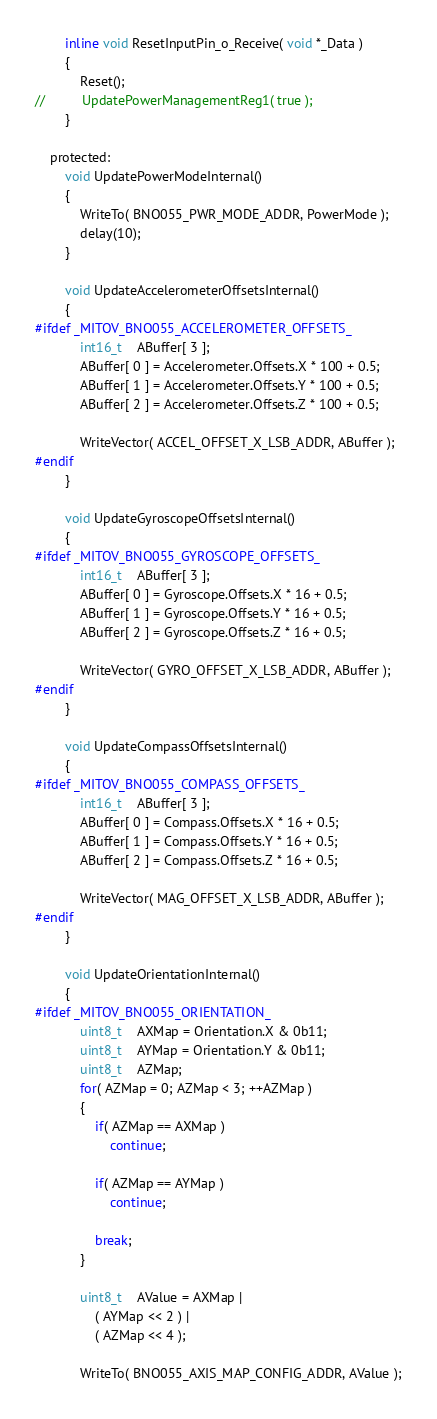Convert code to text. <code><loc_0><loc_0><loc_500><loc_500><_C_>
		inline void ResetInputPin_o_Receive( void *_Data )
		{
			Reset();
//			UpdatePowerManagementReg1( true );
		}

	protected:
		void UpdatePowerModeInternal()
		{
			WriteTo( BNO055_PWR_MODE_ADDR, PowerMode );
			delay(10);
		}

		void UpdateAccelerometerOffsetsInternal()
		{
#ifdef _MITOV_BNO055_ACCELEROMETER_OFFSETS_
			int16_t	ABuffer[ 3 ];
			ABuffer[ 0 ] = Accelerometer.Offsets.X * 100 + 0.5;
			ABuffer[ 1 ] = Accelerometer.Offsets.Y * 100 + 0.5;
			ABuffer[ 2 ] = Accelerometer.Offsets.Z * 100 + 0.5;

			WriteVector( ACCEL_OFFSET_X_LSB_ADDR, ABuffer );
#endif
		}

		void UpdateGyroscopeOffsetsInternal()
		{
#ifdef _MITOV_BNO055_GYROSCOPE_OFFSETS_
			int16_t	ABuffer[ 3 ];
			ABuffer[ 0 ] = Gyroscope.Offsets.X * 16 + 0.5;
			ABuffer[ 1 ] = Gyroscope.Offsets.Y * 16 + 0.5;
			ABuffer[ 2 ] = Gyroscope.Offsets.Z * 16 + 0.5;

			WriteVector( GYRO_OFFSET_X_LSB_ADDR, ABuffer );
#endif
		}

		void UpdateCompassOffsetsInternal()
		{
#ifdef _MITOV_BNO055_COMPASS_OFFSETS_
			int16_t	ABuffer[ 3 ];
			ABuffer[ 0 ] = Compass.Offsets.X * 16 + 0.5;
			ABuffer[ 1 ] = Compass.Offsets.Y * 16 + 0.5;
			ABuffer[ 2 ] = Compass.Offsets.Z * 16 + 0.5;

			WriteVector( MAG_OFFSET_X_LSB_ADDR, ABuffer );
#endif
		}

		void UpdateOrientationInternal()
		{
#ifdef _MITOV_BNO055_ORIENTATION_
			uint8_t	AXMap = Orientation.X & 0b11;
			uint8_t	AYMap = Orientation.Y & 0b11;
			uint8_t	AZMap;
			for( AZMap = 0; AZMap < 3; ++AZMap )
			{
				if( AZMap == AXMap )
					continue;

				if( AZMap == AYMap )
					continue;

				break;
			}

			uint8_t	AValue = AXMap |
				( AYMap << 2 ) |
				( AZMap << 4 );

			WriteTo( BNO055_AXIS_MAP_CONFIG_ADDR, AValue );
</code> 